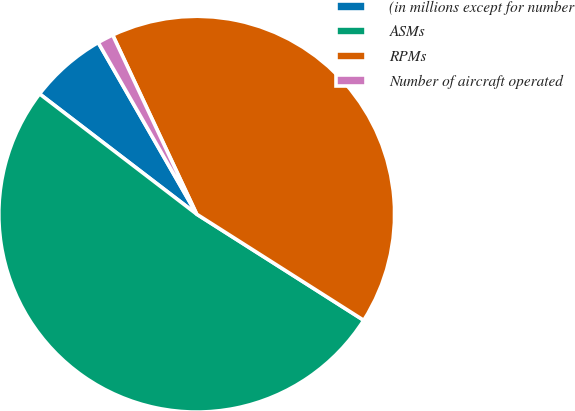Convert chart. <chart><loc_0><loc_0><loc_500><loc_500><pie_chart><fcel>(in millions except for number<fcel>ASMs<fcel>RPMs<fcel>Number of aircraft operated<nl><fcel>6.31%<fcel>51.39%<fcel>40.99%<fcel>1.31%<nl></chart> 